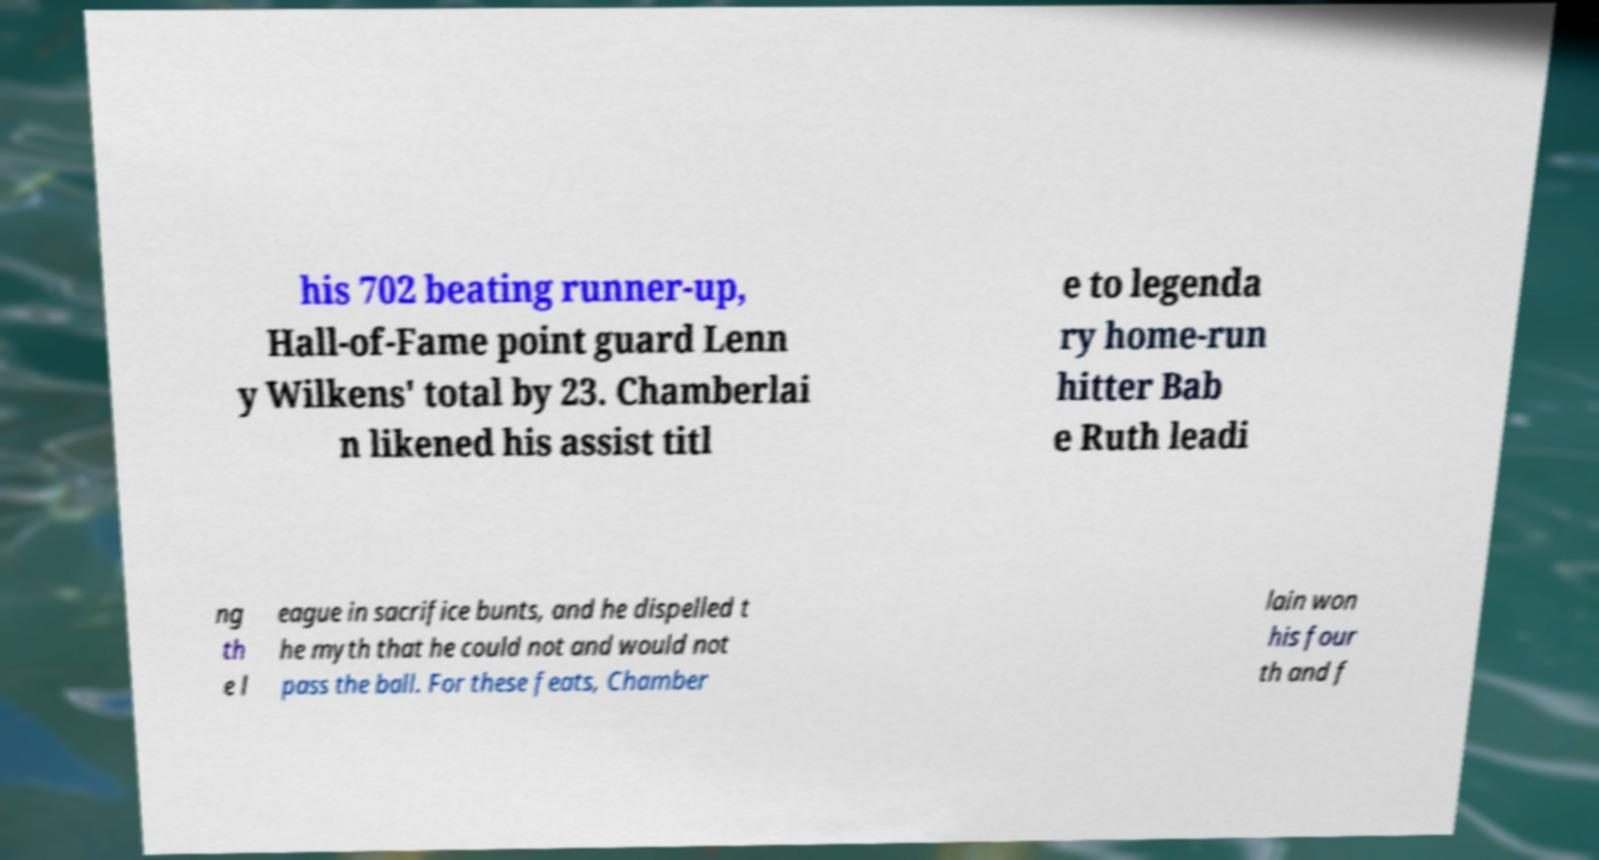Can you accurately transcribe the text from the provided image for me? his 702 beating runner-up, Hall-of-Fame point guard Lenn y Wilkens' total by 23. Chamberlai n likened his assist titl e to legenda ry home-run hitter Bab e Ruth leadi ng th e l eague in sacrifice bunts, and he dispelled t he myth that he could not and would not pass the ball. For these feats, Chamber lain won his four th and f 